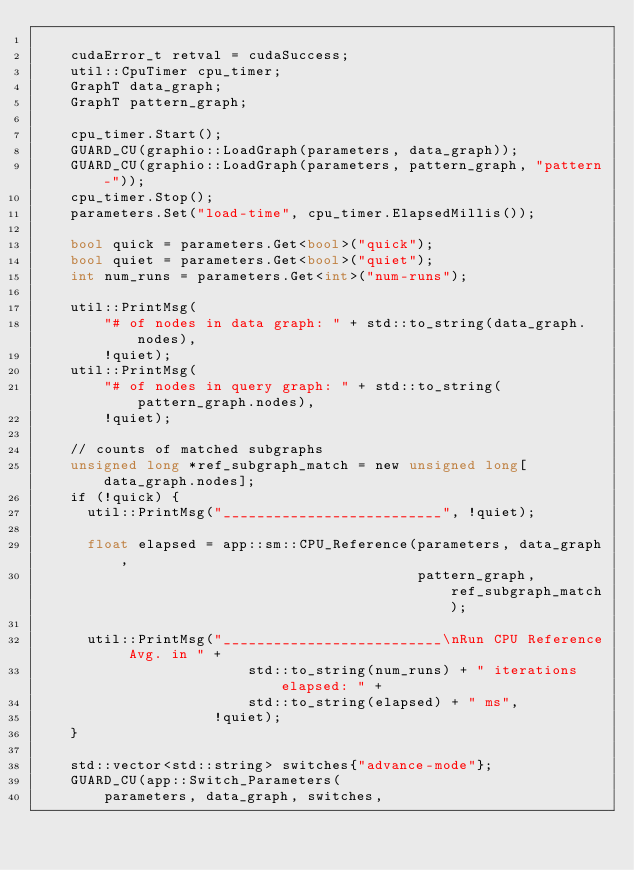Convert code to text. <code><loc_0><loc_0><loc_500><loc_500><_Cuda_>
    cudaError_t retval = cudaSuccess;
    util::CpuTimer cpu_timer;
    GraphT data_graph;
    GraphT pattern_graph;

    cpu_timer.Start();
    GUARD_CU(graphio::LoadGraph(parameters, data_graph));
    GUARD_CU(graphio::LoadGraph(parameters, pattern_graph, "pattern-"));
    cpu_timer.Stop();
    parameters.Set("load-time", cpu_timer.ElapsedMillis());

    bool quick = parameters.Get<bool>("quick");
    bool quiet = parameters.Get<bool>("quiet");
    int num_runs = parameters.Get<int>("num-runs");

    util::PrintMsg(
        "# of nodes in data graph: " + std::to_string(data_graph.nodes),
        !quiet);
    util::PrintMsg(
        "# of nodes in query graph: " + std::to_string(pattern_graph.nodes),
        !quiet);

    // counts of matched subgraphs
    unsigned long *ref_subgraph_match = new unsigned long[data_graph.nodes];
    if (!quick) {
      util::PrintMsg("__________________________", !quiet);

      float elapsed = app::sm::CPU_Reference(parameters, data_graph,
                                             pattern_graph, ref_subgraph_match);

      util::PrintMsg("__________________________\nRun CPU Reference Avg. in " +
                         std::to_string(num_runs) + " iterations elapsed: " +
                         std::to_string(elapsed) + " ms",
                     !quiet);
    }

    std::vector<std::string> switches{"advance-mode"};
    GUARD_CU(app::Switch_Parameters(
        parameters, data_graph, switches,</code> 